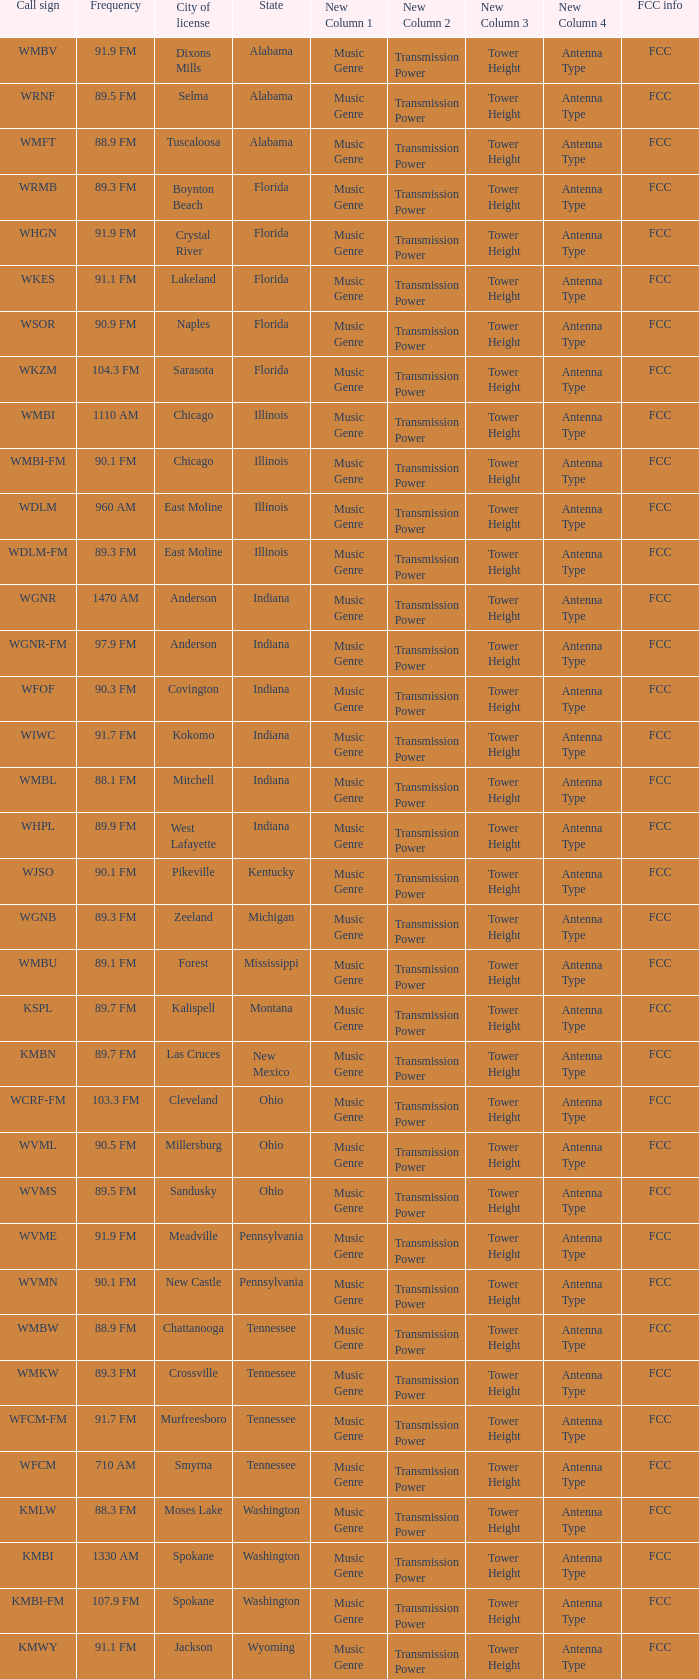What is the FCC info for the radio station in West Lafayette, Indiana? FCC. 